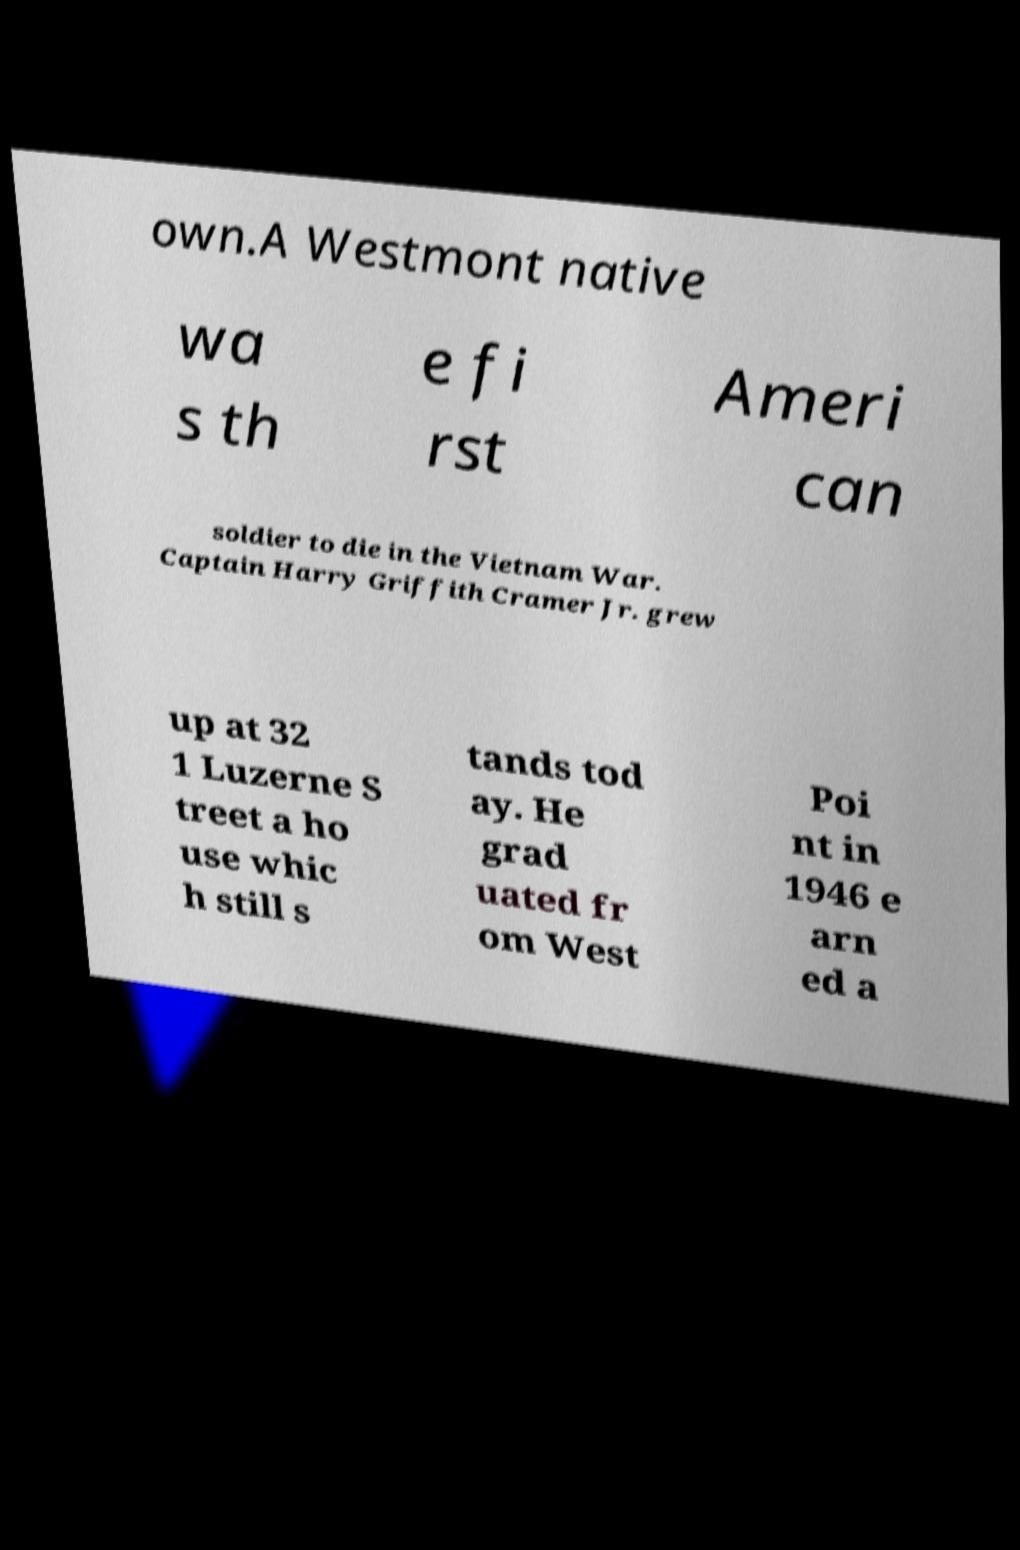Can you read and provide the text displayed in the image?This photo seems to have some interesting text. Can you extract and type it out for me? own.A Westmont native wa s th e fi rst Ameri can soldier to die in the Vietnam War. Captain Harry Griffith Cramer Jr. grew up at 32 1 Luzerne S treet a ho use whic h still s tands tod ay. He grad uated fr om West Poi nt in 1946 e arn ed a 